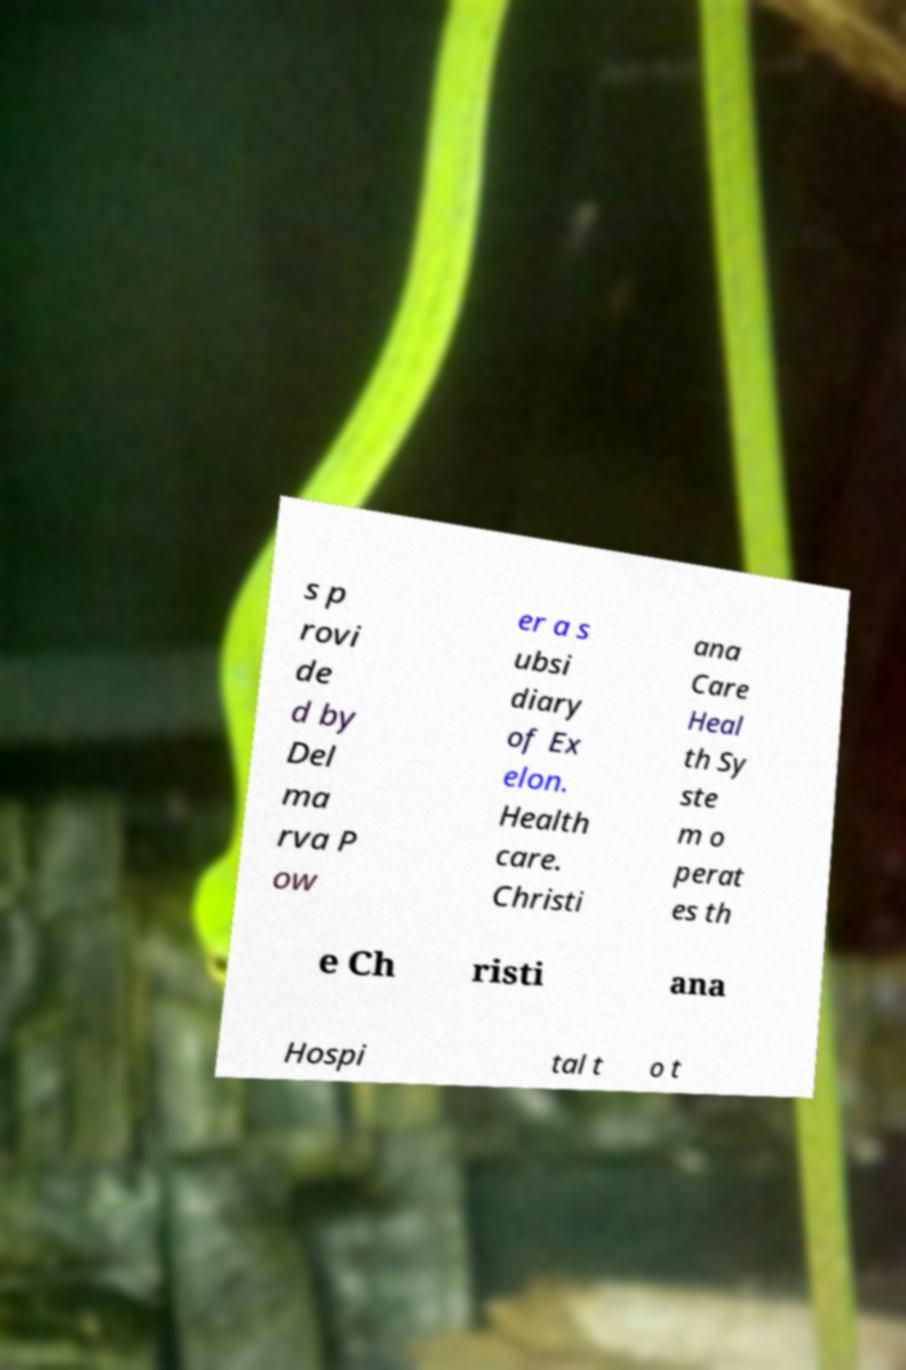There's text embedded in this image that I need extracted. Can you transcribe it verbatim? s p rovi de d by Del ma rva P ow er a s ubsi diary of Ex elon. Health care. Christi ana Care Heal th Sy ste m o perat es th e Ch risti ana Hospi tal t o t 